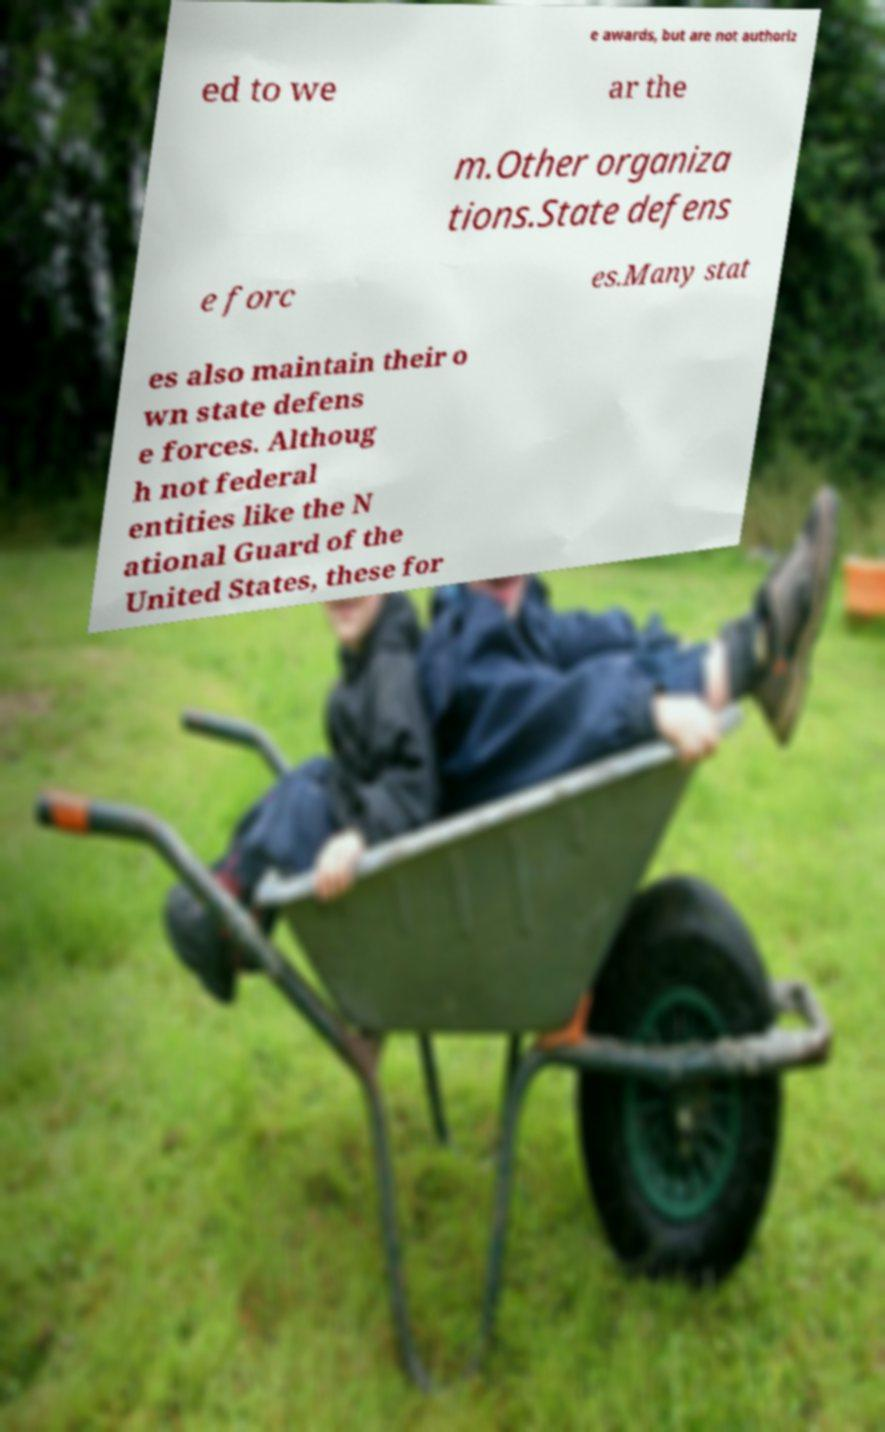Please read and relay the text visible in this image. What does it say? e awards, but are not authoriz ed to we ar the m.Other organiza tions.State defens e forc es.Many stat es also maintain their o wn state defens e forces. Althoug h not federal entities like the N ational Guard of the United States, these for 